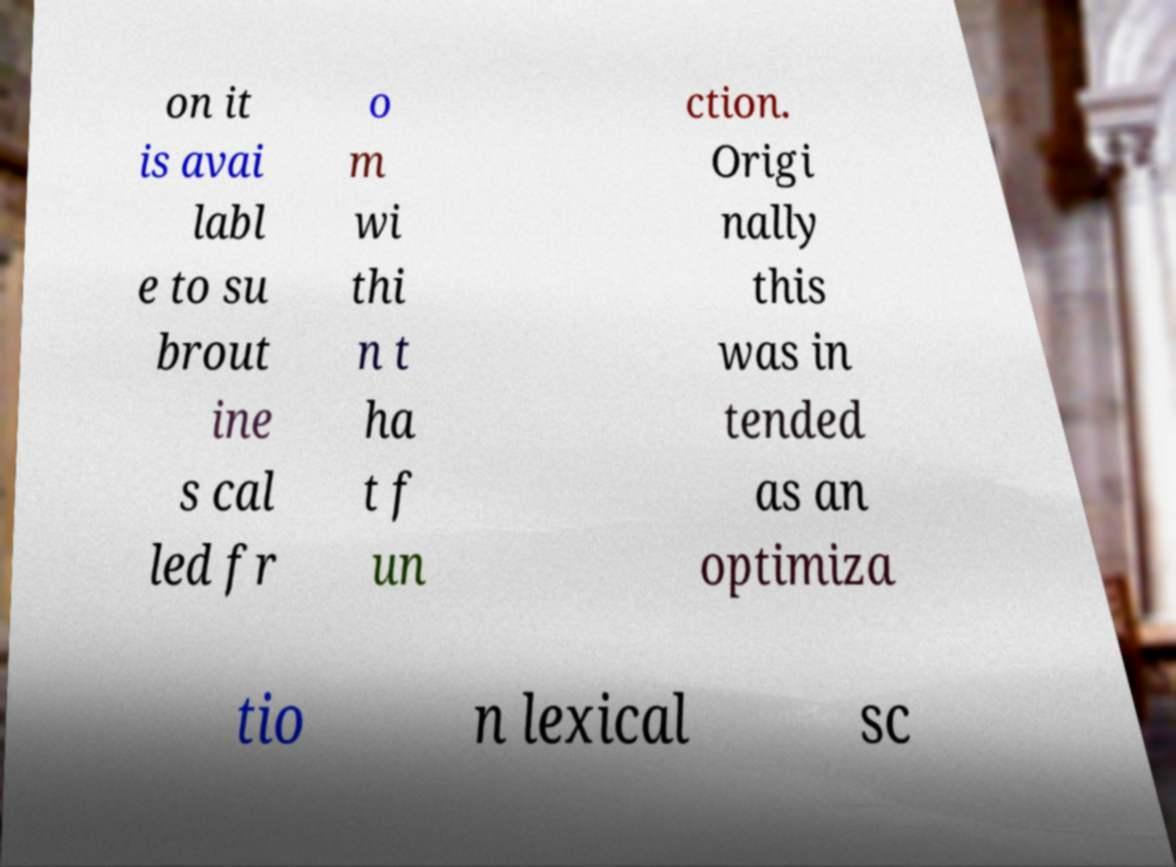Can you read and provide the text displayed in the image?This photo seems to have some interesting text. Can you extract and type it out for me? on it is avai labl e to su brout ine s cal led fr o m wi thi n t ha t f un ction. Origi nally this was in tended as an optimiza tio n lexical sc 